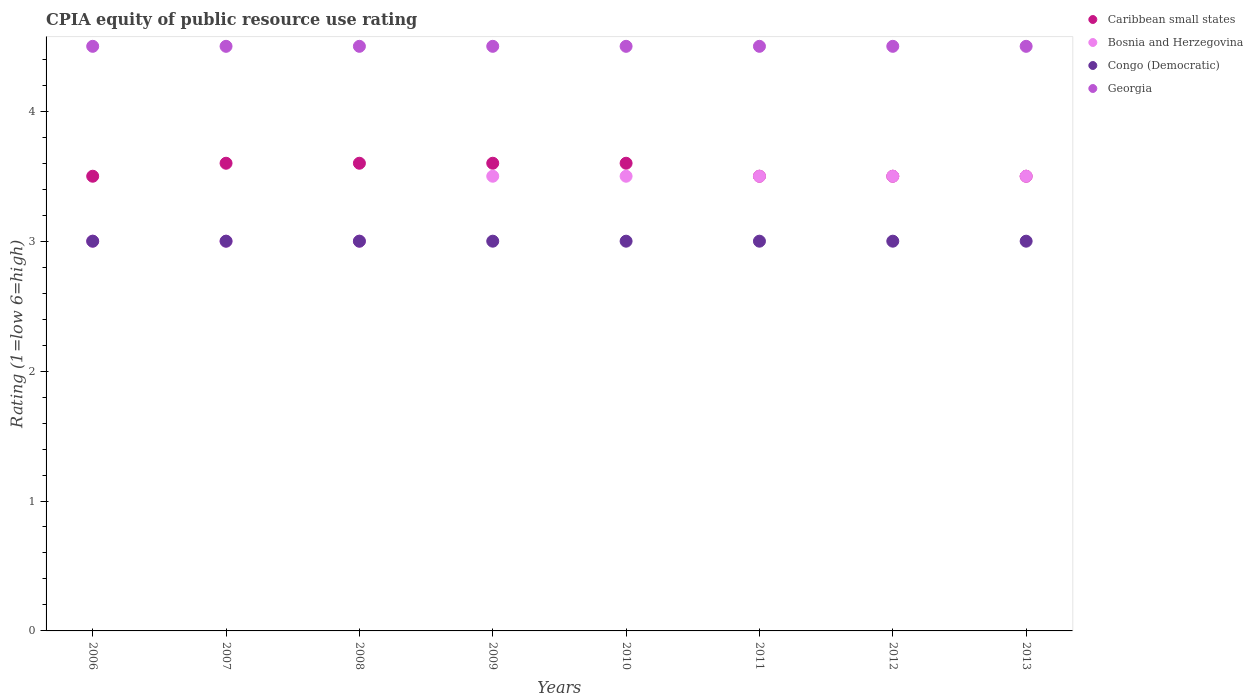How many different coloured dotlines are there?
Keep it short and to the point. 4. Across all years, what is the maximum CPIA rating in Georgia?
Make the answer very short. 4.5. What is the difference between the CPIA rating in Caribbean small states in 2009 and the CPIA rating in Georgia in 2007?
Offer a very short reply. -0.9. What is the average CPIA rating in Caribbean small states per year?
Provide a succinct answer. 3.55. In how many years, is the CPIA rating in Congo (Democratic) greater than 1?
Give a very brief answer. 8. What is the ratio of the CPIA rating in Congo (Democratic) in 2009 to that in 2013?
Your answer should be compact. 1. Is the CPIA rating in Caribbean small states in 2006 less than that in 2011?
Provide a short and direct response. No. Is the difference between the CPIA rating in Bosnia and Herzegovina in 2007 and 2008 greater than the difference between the CPIA rating in Georgia in 2007 and 2008?
Your answer should be compact. No. Is the sum of the CPIA rating in Congo (Democratic) in 2007 and 2009 greater than the maximum CPIA rating in Caribbean small states across all years?
Provide a succinct answer. Yes. Is it the case that in every year, the sum of the CPIA rating in Caribbean small states and CPIA rating in Congo (Democratic)  is greater than the CPIA rating in Bosnia and Herzegovina?
Make the answer very short. Yes. Is the CPIA rating in Congo (Democratic) strictly greater than the CPIA rating in Georgia over the years?
Your response must be concise. No. How many dotlines are there?
Make the answer very short. 4. How many years are there in the graph?
Give a very brief answer. 8. Are the values on the major ticks of Y-axis written in scientific E-notation?
Provide a short and direct response. No. Where does the legend appear in the graph?
Offer a very short reply. Top right. How are the legend labels stacked?
Provide a succinct answer. Vertical. What is the title of the graph?
Offer a very short reply. CPIA equity of public resource use rating. Does "Tuvalu" appear as one of the legend labels in the graph?
Your response must be concise. No. What is the label or title of the Y-axis?
Your answer should be very brief. Rating (1=low 6=high). What is the Rating (1=low 6=high) in Bosnia and Herzegovina in 2006?
Keep it short and to the point. 3. What is the Rating (1=low 6=high) of Congo (Democratic) in 2006?
Your answer should be compact. 3. What is the Rating (1=low 6=high) of Georgia in 2006?
Keep it short and to the point. 4.5. What is the Rating (1=low 6=high) of Caribbean small states in 2007?
Provide a succinct answer. 3.6. What is the Rating (1=low 6=high) of Bosnia and Herzegovina in 2007?
Make the answer very short. 3. What is the Rating (1=low 6=high) in Congo (Democratic) in 2007?
Keep it short and to the point. 3. What is the Rating (1=low 6=high) in Caribbean small states in 2009?
Your response must be concise. 3.6. What is the Rating (1=low 6=high) in Congo (Democratic) in 2009?
Your answer should be very brief. 3. What is the Rating (1=low 6=high) of Caribbean small states in 2010?
Offer a very short reply. 3.6. What is the Rating (1=low 6=high) in Caribbean small states in 2011?
Give a very brief answer. 3.5. What is the Rating (1=low 6=high) of Bosnia and Herzegovina in 2011?
Keep it short and to the point. 3.5. What is the Rating (1=low 6=high) of Caribbean small states in 2012?
Offer a very short reply. 3.5. What is the Rating (1=low 6=high) of Bosnia and Herzegovina in 2013?
Give a very brief answer. 3.5. What is the Rating (1=low 6=high) of Georgia in 2013?
Your answer should be compact. 4.5. Across all years, what is the maximum Rating (1=low 6=high) in Caribbean small states?
Provide a succinct answer. 3.6. Across all years, what is the maximum Rating (1=low 6=high) of Bosnia and Herzegovina?
Provide a short and direct response. 3.5. Across all years, what is the minimum Rating (1=low 6=high) in Bosnia and Herzegovina?
Offer a very short reply. 3. Across all years, what is the minimum Rating (1=low 6=high) of Congo (Democratic)?
Provide a short and direct response. 3. Across all years, what is the minimum Rating (1=low 6=high) in Georgia?
Your response must be concise. 4.5. What is the total Rating (1=low 6=high) in Caribbean small states in the graph?
Ensure brevity in your answer.  28.4. What is the total Rating (1=low 6=high) of Georgia in the graph?
Your answer should be very brief. 36. What is the difference between the Rating (1=low 6=high) in Caribbean small states in 2006 and that in 2008?
Your response must be concise. -0.1. What is the difference between the Rating (1=low 6=high) of Congo (Democratic) in 2006 and that in 2008?
Make the answer very short. 0. What is the difference between the Rating (1=low 6=high) in Bosnia and Herzegovina in 2006 and that in 2009?
Provide a succinct answer. -0.5. What is the difference between the Rating (1=low 6=high) of Bosnia and Herzegovina in 2006 and that in 2010?
Offer a very short reply. -0.5. What is the difference between the Rating (1=low 6=high) of Congo (Democratic) in 2006 and that in 2010?
Offer a very short reply. 0. What is the difference between the Rating (1=low 6=high) in Bosnia and Herzegovina in 2006 and that in 2011?
Keep it short and to the point. -0.5. What is the difference between the Rating (1=low 6=high) of Congo (Democratic) in 2006 and that in 2011?
Your response must be concise. 0. What is the difference between the Rating (1=low 6=high) of Georgia in 2006 and that in 2011?
Give a very brief answer. 0. What is the difference between the Rating (1=low 6=high) in Caribbean small states in 2006 and that in 2012?
Provide a succinct answer. 0. What is the difference between the Rating (1=low 6=high) of Bosnia and Herzegovina in 2006 and that in 2013?
Your answer should be very brief. -0.5. What is the difference between the Rating (1=low 6=high) in Congo (Democratic) in 2006 and that in 2013?
Ensure brevity in your answer.  0. What is the difference between the Rating (1=low 6=high) in Bosnia and Herzegovina in 2007 and that in 2008?
Offer a terse response. 0. What is the difference between the Rating (1=low 6=high) in Congo (Democratic) in 2007 and that in 2008?
Give a very brief answer. 0. What is the difference between the Rating (1=low 6=high) of Georgia in 2007 and that in 2008?
Provide a succinct answer. 0. What is the difference between the Rating (1=low 6=high) in Caribbean small states in 2007 and that in 2009?
Provide a short and direct response. 0. What is the difference between the Rating (1=low 6=high) of Bosnia and Herzegovina in 2007 and that in 2009?
Make the answer very short. -0.5. What is the difference between the Rating (1=low 6=high) of Congo (Democratic) in 2007 and that in 2009?
Give a very brief answer. 0. What is the difference between the Rating (1=low 6=high) in Georgia in 2007 and that in 2009?
Make the answer very short. 0. What is the difference between the Rating (1=low 6=high) of Bosnia and Herzegovina in 2007 and that in 2010?
Offer a terse response. -0.5. What is the difference between the Rating (1=low 6=high) in Caribbean small states in 2007 and that in 2011?
Make the answer very short. 0.1. What is the difference between the Rating (1=low 6=high) in Congo (Democratic) in 2007 and that in 2011?
Your answer should be very brief. 0. What is the difference between the Rating (1=low 6=high) of Caribbean small states in 2007 and that in 2012?
Ensure brevity in your answer.  0.1. What is the difference between the Rating (1=low 6=high) of Congo (Democratic) in 2007 and that in 2012?
Offer a very short reply. 0. What is the difference between the Rating (1=low 6=high) in Bosnia and Herzegovina in 2007 and that in 2013?
Make the answer very short. -0.5. What is the difference between the Rating (1=low 6=high) of Congo (Democratic) in 2007 and that in 2013?
Provide a succinct answer. 0. What is the difference between the Rating (1=low 6=high) of Georgia in 2007 and that in 2013?
Offer a very short reply. 0. What is the difference between the Rating (1=low 6=high) of Bosnia and Herzegovina in 2008 and that in 2009?
Your answer should be very brief. -0.5. What is the difference between the Rating (1=low 6=high) in Congo (Democratic) in 2008 and that in 2010?
Make the answer very short. 0. What is the difference between the Rating (1=low 6=high) in Caribbean small states in 2008 and that in 2011?
Provide a succinct answer. 0.1. What is the difference between the Rating (1=low 6=high) in Congo (Democratic) in 2008 and that in 2011?
Offer a very short reply. 0. What is the difference between the Rating (1=low 6=high) of Georgia in 2008 and that in 2011?
Your answer should be compact. 0. What is the difference between the Rating (1=low 6=high) of Caribbean small states in 2008 and that in 2012?
Offer a terse response. 0.1. What is the difference between the Rating (1=low 6=high) in Bosnia and Herzegovina in 2008 and that in 2012?
Your answer should be compact. -0.5. What is the difference between the Rating (1=low 6=high) in Georgia in 2008 and that in 2012?
Ensure brevity in your answer.  0. What is the difference between the Rating (1=low 6=high) of Caribbean small states in 2008 and that in 2013?
Make the answer very short. 0.1. What is the difference between the Rating (1=low 6=high) in Bosnia and Herzegovina in 2008 and that in 2013?
Your answer should be very brief. -0.5. What is the difference between the Rating (1=low 6=high) in Georgia in 2008 and that in 2013?
Offer a very short reply. 0. What is the difference between the Rating (1=low 6=high) in Bosnia and Herzegovina in 2009 and that in 2010?
Provide a succinct answer. 0. What is the difference between the Rating (1=low 6=high) of Georgia in 2009 and that in 2010?
Make the answer very short. 0. What is the difference between the Rating (1=low 6=high) of Caribbean small states in 2009 and that in 2011?
Offer a terse response. 0.1. What is the difference between the Rating (1=low 6=high) of Bosnia and Herzegovina in 2009 and that in 2011?
Offer a very short reply. 0. What is the difference between the Rating (1=low 6=high) in Bosnia and Herzegovina in 2009 and that in 2012?
Offer a terse response. 0. What is the difference between the Rating (1=low 6=high) of Congo (Democratic) in 2009 and that in 2012?
Your answer should be very brief. 0. What is the difference between the Rating (1=low 6=high) of Caribbean small states in 2009 and that in 2013?
Give a very brief answer. 0.1. What is the difference between the Rating (1=low 6=high) of Bosnia and Herzegovina in 2009 and that in 2013?
Offer a very short reply. 0. What is the difference between the Rating (1=low 6=high) of Congo (Democratic) in 2009 and that in 2013?
Your answer should be compact. 0. What is the difference between the Rating (1=low 6=high) in Caribbean small states in 2010 and that in 2011?
Provide a succinct answer. 0.1. What is the difference between the Rating (1=low 6=high) of Congo (Democratic) in 2010 and that in 2011?
Your answer should be compact. 0. What is the difference between the Rating (1=low 6=high) of Caribbean small states in 2010 and that in 2012?
Your answer should be very brief. 0.1. What is the difference between the Rating (1=low 6=high) of Bosnia and Herzegovina in 2010 and that in 2012?
Keep it short and to the point. 0. What is the difference between the Rating (1=low 6=high) in Congo (Democratic) in 2010 and that in 2012?
Provide a short and direct response. 0. What is the difference between the Rating (1=low 6=high) of Georgia in 2010 and that in 2012?
Provide a short and direct response. 0. What is the difference between the Rating (1=low 6=high) in Caribbean small states in 2010 and that in 2013?
Your answer should be compact. 0.1. What is the difference between the Rating (1=low 6=high) in Bosnia and Herzegovina in 2010 and that in 2013?
Make the answer very short. 0. What is the difference between the Rating (1=low 6=high) in Congo (Democratic) in 2010 and that in 2013?
Make the answer very short. 0. What is the difference between the Rating (1=low 6=high) of Georgia in 2010 and that in 2013?
Offer a terse response. 0. What is the difference between the Rating (1=low 6=high) in Caribbean small states in 2011 and that in 2012?
Make the answer very short. 0. What is the difference between the Rating (1=low 6=high) of Bosnia and Herzegovina in 2011 and that in 2013?
Make the answer very short. 0. What is the difference between the Rating (1=low 6=high) in Congo (Democratic) in 2011 and that in 2013?
Make the answer very short. 0. What is the difference between the Rating (1=low 6=high) of Caribbean small states in 2012 and that in 2013?
Keep it short and to the point. 0. What is the difference between the Rating (1=low 6=high) in Bosnia and Herzegovina in 2012 and that in 2013?
Your answer should be very brief. 0. What is the difference between the Rating (1=low 6=high) in Georgia in 2012 and that in 2013?
Make the answer very short. 0. What is the difference between the Rating (1=low 6=high) of Congo (Democratic) in 2006 and the Rating (1=low 6=high) of Georgia in 2007?
Offer a terse response. -1.5. What is the difference between the Rating (1=low 6=high) of Caribbean small states in 2006 and the Rating (1=low 6=high) of Bosnia and Herzegovina in 2008?
Make the answer very short. 0.5. What is the difference between the Rating (1=low 6=high) of Caribbean small states in 2006 and the Rating (1=low 6=high) of Congo (Democratic) in 2008?
Keep it short and to the point. 0.5. What is the difference between the Rating (1=low 6=high) in Bosnia and Herzegovina in 2006 and the Rating (1=low 6=high) in Congo (Democratic) in 2008?
Provide a succinct answer. 0. What is the difference between the Rating (1=low 6=high) in Bosnia and Herzegovina in 2006 and the Rating (1=low 6=high) in Georgia in 2008?
Provide a succinct answer. -1.5. What is the difference between the Rating (1=low 6=high) in Caribbean small states in 2006 and the Rating (1=low 6=high) in Congo (Democratic) in 2009?
Your answer should be compact. 0.5. What is the difference between the Rating (1=low 6=high) in Caribbean small states in 2006 and the Rating (1=low 6=high) in Congo (Democratic) in 2010?
Ensure brevity in your answer.  0.5. What is the difference between the Rating (1=low 6=high) of Bosnia and Herzegovina in 2006 and the Rating (1=low 6=high) of Congo (Democratic) in 2010?
Keep it short and to the point. 0. What is the difference between the Rating (1=low 6=high) of Caribbean small states in 2006 and the Rating (1=low 6=high) of Bosnia and Herzegovina in 2011?
Make the answer very short. 0. What is the difference between the Rating (1=low 6=high) of Caribbean small states in 2006 and the Rating (1=low 6=high) of Congo (Democratic) in 2011?
Your answer should be very brief. 0.5. What is the difference between the Rating (1=low 6=high) in Caribbean small states in 2006 and the Rating (1=low 6=high) in Georgia in 2011?
Offer a terse response. -1. What is the difference between the Rating (1=low 6=high) in Bosnia and Herzegovina in 2006 and the Rating (1=low 6=high) in Georgia in 2011?
Your answer should be compact. -1.5. What is the difference between the Rating (1=low 6=high) in Caribbean small states in 2006 and the Rating (1=low 6=high) in Bosnia and Herzegovina in 2012?
Provide a short and direct response. 0. What is the difference between the Rating (1=low 6=high) in Caribbean small states in 2006 and the Rating (1=low 6=high) in Georgia in 2012?
Your answer should be compact. -1. What is the difference between the Rating (1=low 6=high) of Caribbean small states in 2006 and the Rating (1=low 6=high) of Congo (Democratic) in 2013?
Your answer should be very brief. 0.5. What is the difference between the Rating (1=low 6=high) in Bosnia and Herzegovina in 2006 and the Rating (1=low 6=high) in Congo (Democratic) in 2013?
Your answer should be very brief. 0. What is the difference between the Rating (1=low 6=high) of Congo (Democratic) in 2006 and the Rating (1=low 6=high) of Georgia in 2013?
Offer a very short reply. -1.5. What is the difference between the Rating (1=low 6=high) in Caribbean small states in 2007 and the Rating (1=low 6=high) in Congo (Democratic) in 2008?
Your answer should be very brief. 0.6. What is the difference between the Rating (1=low 6=high) in Congo (Democratic) in 2007 and the Rating (1=low 6=high) in Georgia in 2008?
Give a very brief answer. -1.5. What is the difference between the Rating (1=low 6=high) of Caribbean small states in 2007 and the Rating (1=low 6=high) of Congo (Democratic) in 2009?
Keep it short and to the point. 0.6. What is the difference between the Rating (1=low 6=high) in Caribbean small states in 2007 and the Rating (1=low 6=high) in Georgia in 2009?
Offer a very short reply. -0.9. What is the difference between the Rating (1=low 6=high) of Bosnia and Herzegovina in 2007 and the Rating (1=low 6=high) of Georgia in 2009?
Your answer should be very brief. -1.5. What is the difference between the Rating (1=low 6=high) of Caribbean small states in 2007 and the Rating (1=low 6=high) of Bosnia and Herzegovina in 2010?
Your answer should be compact. 0.1. What is the difference between the Rating (1=low 6=high) of Caribbean small states in 2007 and the Rating (1=low 6=high) of Georgia in 2010?
Your answer should be compact. -0.9. What is the difference between the Rating (1=low 6=high) in Bosnia and Herzegovina in 2007 and the Rating (1=low 6=high) in Congo (Democratic) in 2010?
Provide a short and direct response. 0. What is the difference between the Rating (1=low 6=high) of Bosnia and Herzegovina in 2007 and the Rating (1=low 6=high) of Georgia in 2010?
Offer a very short reply. -1.5. What is the difference between the Rating (1=low 6=high) of Congo (Democratic) in 2007 and the Rating (1=low 6=high) of Georgia in 2010?
Give a very brief answer. -1.5. What is the difference between the Rating (1=low 6=high) in Bosnia and Herzegovina in 2007 and the Rating (1=low 6=high) in Congo (Democratic) in 2011?
Make the answer very short. 0. What is the difference between the Rating (1=low 6=high) in Congo (Democratic) in 2007 and the Rating (1=low 6=high) in Georgia in 2011?
Give a very brief answer. -1.5. What is the difference between the Rating (1=low 6=high) of Caribbean small states in 2007 and the Rating (1=low 6=high) of Congo (Democratic) in 2012?
Ensure brevity in your answer.  0.6. What is the difference between the Rating (1=low 6=high) in Bosnia and Herzegovina in 2007 and the Rating (1=low 6=high) in Congo (Democratic) in 2012?
Keep it short and to the point. 0. What is the difference between the Rating (1=low 6=high) in Bosnia and Herzegovina in 2007 and the Rating (1=low 6=high) in Georgia in 2012?
Offer a very short reply. -1.5. What is the difference between the Rating (1=low 6=high) in Congo (Democratic) in 2007 and the Rating (1=low 6=high) in Georgia in 2012?
Your response must be concise. -1.5. What is the difference between the Rating (1=low 6=high) in Caribbean small states in 2007 and the Rating (1=low 6=high) in Georgia in 2013?
Provide a succinct answer. -0.9. What is the difference between the Rating (1=low 6=high) of Bosnia and Herzegovina in 2007 and the Rating (1=low 6=high) of Congo (Democratic) in 2013?
Offer a terse response. 0. What is the difference between the Rating (1=low 6=high) of Congo (Democratic) in 2007 and the Rating (1=low 6=high) of Georgia in 2013?
Your answer should be compact. -1.5. What is the difference between the Rating (1=low 6=high) of Caribbean small states in 2008 and the Rating (1=low 6=high) of Georgia in 2009?
Provide a short and direct response. -0.9. What is the difference between the Rating (1=low 6=high) in Congo (Democratic) in 2008 and the Rating (1=low 6=high) in Georgia in 2009?
Provide a succinct answer. -1.5. What is the difference between the Rating (1=low 6=high) in Caribbean small states in 2008 and the Rating (1=low 6=high) in Bosnia and Herzegovina in 2010?
Ensure brevity in your answer.  0.1. What is the difference between the Rating (1=low 6=high) of Caribbean small states in 2008 and the Rating (1=low 6=high) of Congo (Democratic) in 2010?
Ensure brevity in your answer.  0.6. What is the difference between the Rating (1=low 6=high) in Caribbean small states in 2008 and the Rating (1=low 6=high) in Georgia in 2010?
Provide a succinct answer. -0.9. What is the difference between the Rating (1=low 6=high) in Bosnia and Herzegovina in 2008 and the Rating (1=low 6=high) in Congo (Democratic) in 2010?
Your answer should be compact. 0. What is the difference between the Rating (1=low 6=high) in Caribbean small states in 2008 and the Rating (1=low 6=high) in Bosnia and Herzegovina in 2011?
Your answer should be very brief. 0.1. What is the difference between the Rating (1=low 6=high) in Caribbean small states in 2008 and the Rating (1=low 6=high) in Georgia in 2011?
Your answer should be compact. -0.9. What is the difference between the Rating (1=low 6=high) of Bosnia and Herzegovina in 2008 and the Rating (1=low 6=high) of Georgia in 2011?
Keep it short and to the point. -1.5. What is the difference between the Rating (1=low 6=high) in Congo (Democratic) in 2008 and the Rating (1=low 6=high) in Georgia in 2011?
Your answer should be very brief. -1.5. What is the difference between the Rating (1=low 6=high) of Caribbean small states in 2008 and the Rating (1=low 6=high) of Bosnia and Herzegovina in 2012?
Offer a very short reply. 0.1. What is the difference between the Rating (1=low 6=high) in Caribbean small states in 2008 and the Rating (1=low 6=high) in Georgia in 2012?
Your answer should be compact. -0.9. What is the difference between the Rating (1=low 6=high) in Bosnia and Herzegovina in 2008 and the Rating (1=low 6=high) in Congo (Democratic) in 2012?
Offer a very short reply. 0. What is the difference between the Rating (1=low 6=high) in Bosnia and Herzegovina in 2008 and the Rating (1=low 6=high) in Georgia in 2012?
Offer a very short reply. -1.5. What is the difference between the Rating (1=low 6=high) in Congo (Democratic) in 2008 and the Rating (1=low 6=high) in Georgia in 2012?
Give a very brief answer. -1.5. What is the difference between the Rating (1=low 6=high) of Caribbean small states in 2008 and the Rating (1=low 6=high) of Bosnia and Herzegovina in 2013?
Ensure brevity in your answer.  0.1. What is the difference between the Rating (1=low 6=high) in Caribbean small states in 2008 and the Rating (1=low 6=high) in Congo (Democratic) in 2013?
Ensure brevity in your answer.  0.6. What is the difference between the Rating (1=low 6=high) of Bosnia and Herzegovina in 2008 and the Rating (1=low 6=high) of Congo (Democratic) in 2013?
Offer a terse response. 0. What is the difference between the Rating (1=low 6=high) in Bosnia and Herzegovina in 2008 and the Rating (1=low 6=high) in Georgia in 2013?
Make the answer very short. -1.5. What is the difference between the Rating (1=low 6=high) of Caribbean small states in 2009 and the Rating (1=low 6=high) of Bosnia and Herzegovina in 2010?
Ensure brevity in your answer.  0.1. What is the difference between the Rating (1=low 6=high) in Bosnia and Herzegovina in 2009 and the Rating (1=low 6=high) in Georgia in 2010?
Offer a very short reply. -1. What is the difference between the Rating (1=low 6=high) in Caribbean small states in 2009 and the Rating (1=low 6=high) in Bosnia and Herzegovina in 2011?
Offer a terse response. 0.1. What is the difference between the Rating (1=low 6=high) in Caribbean small states in 2009 and the Rating (1=low 6=high) in Georgia in 2011?
Provide a succinct answer. -0.9. What is the difference between the Rating (1=low 6=high) in Congo (Democratic) in 2009 and the Rating (1=low 6=high) in Georgia in 2011?
Provide a succinct answer. -1.5. What is the difference between the Rating (1=low 6=high) in Caribbean small states in 2009 and the Rating (1=low 6=high) in Bosnia and Herzegovina in 2012?
Offer a very short reply. 0.1. What is the difference between the Rating (1=low 6=high) of Caribbean small states in 2009 and the Rating (1=low 6=high) of Congo (Democratic) in 2012?
Offer a very short reply. 0.6. What is the difference between the Rating (1=low 6=high) in Bosnia and Herzegovina in 2009 and the Rating (1=low 6=high) in Georgia in 2012?
Your answer should be compact. -1. What is the difference between the Rating (1=low 6=high) in Caribbean small states in 2009 and the Rating (1=low 6=high) in Congo (Democratic) in 2013?
Offer a terse response. 0.6. What is the difference between the Rating (1=low 6=high) in Bosnia and Herzegovina in 2009 and the Rating (1=low 6=high) in Georgia in 2013?
Ensure brevity in your answer.  -1. What is the difference between the Rating (1=low 6=high) in Congo (Democratic) in 2009 and the Rating (1=low 6=high) in Georgia in 2013?
Your answer should be compact. -1.5. What is the difference between the Rating (1=low 6=high) of Caribbean small states in 2010 and the Rating (1=low 6=high) of Georgia in 2011?
Your response must be concise. -0.9. What is the difference between the Rating (1=low 6=high) of Bosnia and Herzegovina in 2010 and the Rating (1=low 6=high) of Congo (Democratic) in 2011?
Offer a very short reply. 0.5. What is the difference between the Rating (1=low 6=high) of Bosnia and Herzegovina in 2010 and the Rating (1=low 6=high) of Georgia in 2011?
Offer a terse response. -1. What is the difference between the Rating (1=low 6=high) in Caribbean small states in 2010 and the Rating (1=low 6=high) in Georgia in 2012?
Provide a succinct answer. -0.9. What is the difference between the Rating (1=low 6=high) in Bosnia and Herzegovina in 2010 and the Rating (1=low 6=high) in Congo (Democratic) in 2012?
Offer a very short reply. 0.5. What is the difference between the Rating (1=low 6=high) in Caribbean small states in 2010 and the Rating (1=low 6=high) in Bosnia and Herzegovina in 2013?
Your response must be concise. 0.1. What is the difference between the Rating (1=low 6=high) of Caribbean small states in 2010 and the Rating (1=low 6=high) of Congo (Democratic) in 2013?
Keep it short and to the point. 0.6. What is the difference between the Rating (1=low 6=high) in Bosnia and Herzegovina in 2010 and the Rating (1=low 6=high) in Congo (Democratic) in 2013?
Offer a terse response. 0.5. What is the difference between the Rating (1=low 6=high) of Bosnia and Herzegovina in 2010 and the Rating (1=low 6=high) of Georgia in 2013?
Your answer should be very brief. -1. What is the difference between the Rating (1=low 6=high) of Congo (Democratic) in 2010 and the Rating (1=low 6=high) of Georgia in 2013?
Your answer should be compact. -1.5. What is the difference between the Rating (1=low 6=high) of Caribbean small states in 2011 and the Rating (1=low 6=high) of Congo (Democratic) in 2012?
Your response must be concise. 0.5. What is the difference between the Rating (1=low 6=high) in Bosnia and Herzegovina in 2011 and the Rating (1=low 6=high) in Georgia in 2012?
Provide a succinct answer. -1. What is the difference between the Rating (1=low 6=high) of Congo (Democratic) in 2011 and the Rating (1=low 6=high) of Georgia in 2012?
Provide a short and direct response. -1.5. What is the difference between the Rating (1=low 6=high) in Caribbean small states in 2011 and the Rating (1=low 6=high) in Bosnia and Herzegovina in 2013?
Ensure brevity in your answer.  0. What is the difference between the Rating (1=low 6=high) in Bosnia and Herzegovina in 2011 and the Rating (1=low 6=high) in Georgia in 2013?
Make the answer very short. -1. What is the difference between the Rating (1=low 6=high) in Congo (Democratic) in 2011 and the Rating (1=low 6=high) in Georgia in 2013?
Your response must be concise. -1.5. What is the difference between the Rating (1=low 6=high) in Caribbean small states in 2012 and the Rating (1=low 6=high) in Bosnia and Herzegovina in 2013?
Offer a very short reply. 0. What is the difference between the Rating (1=low 6=high) in Caribbean small states in 2012 and the Rating (1=low 6=high) in Congo (Democratic) in 2013?
Offer a terse response. 0.5. What is the difference between the Rating (1=low 6=high) in Caribbean small states in 2012 and the Rating (1=low 6=high) in Georgia in 2013?
Your response must be concise. -1. What is the difference between the Rating (1=low 6=high) of Bosnia and Herzegovina in 2012 and the Rating (1=low 6=high) of Georgia in 2013?
Your response must be concise. -1. What is the difference between the Rating (1=low 6=high) in Congo (Democratic) in 2012 and the Rating (1=low 6=high) in Georgia in 2013?
Offer a terse response. -1.5. What is the average Rating (1=low 6=high) of Caribbean small states per year?
Give a very brief answer. 3.55. What is the average Rating (1=low 6=high) in Bosnia and Herzegovina per year?
Provide a succinct answer. 3.31. What is the average Rating (1=low 6=high) in Congo (Democratic) per year?
Offer a very short reply. 3. In the year 2006, what is the difference between the Rating (1=low 6=high) of Caribbean small states and Rating (1=low 6=high) of Congo (Democratic)?
Make the answer very short. 0.5. In the year 2006, what is the difference between the Rating (1=low 6=high) in Bosnia and Herzegovina and Rating (1=low 6=high) in Congo (Democratic)?
Your answer should be compact. 0. In the year 2007, what is the difference between the Rating (1=low 6=high) in Caribbean small states and Rating (1=low 6=high) in Bosnia and Herzegovina?
Your answer should be very brief. 0.6. In the year 2008, what is the difference between the Rating (1=low 6=high) in Caribbean small states and Rating (1=low 6=high) in Georgia?
Your answer should be very brief. -0.9. In the year 2008, what is the difference between the Rating (1=low 6=high) in Bosnia and Herzegovina and Rating (1=low 6=high) in Congo (Democratic)?
Your response must be concise. 0. In the year 2008, what is the difference between the Rating (1=low 6=high) in Bosnia and Herzegovina and Rating (1=low 6=high) in Georgia?
Give a very brief answer. -1.5. In the year 2009, what is the difference between the Rating (1=low 6=high) in Caribbean small states and Rating (1=low 6=high) in Congo (Democratic)?
Your response must be concise. 0.6. In the year 2009, what is the difference between the Rating (1=low 6=high) in Bosnia and Herzegovina and Rating (1=low 6=high) in Georgia?
Your response must be concise. -1. In the year 2009, what is the difference between the Rating (1=low 6=high) of Congo (Democratic) and Rating (1=low 6=high) of Georgia?
Your response must be concise. -1.5. In the year 2010, what is the difference between the Rating (1=low 6=high) in Bosnia and Herzegovina and Rating (1=low 6=high) in Congo (Democratic)?
Your answer should be compact. 0.5. In the year 2011, what is the difference between the Rating (1=low 6=high) in Caribbean small states and Rating (1=low 6=high) in Bosnia and Herzegovina?
Provide a succinct answer. 0. In the year 2011, what is the difference between the Rating (1=low 6=high) of Caribbean small states and Rating (1=low 6=high) of Congo (Democratic)?
Offer a very short reply. 0.5. In the year 2011, what is the difference between the Rating (1=low 6=high) in Bosnia and Herzegovina and Rating (1=low 6=high) in Georgia?
Make the answer very short. -1. In the year 2011, what is the difference between the Rating (1=low 6=high) in Congo (Democratic) and Rating (1=low 6=high) in Georgia?
Keep it short and to the point. -1.5. In the year 2012, what is the difference between the Rating (1=low 6=high) in Caribbean small states and Rating (1=low 6=high) in Congo (Democratic)?
Offer a very short reply. 0.5. In the year 2012, what is the difference between the Rating (1=low 6=high) in Bosnia and Herzegovina and Rating (1=low 6=high) in Congo (Democratic)?
Offer a terse response. 0.5. In the year 2012, what is the difference between the Rating (1=low 6=high) in Bosnia and Herzegovina and Rating (1=low 6=high) in Georgia?
Your answer should be very brief. -1. In the year 2012, what is the difference between the Rating (1=low 6=high) of Congo (Democratic) and Rating (1=low 6=high) of Georgia?
Your answer should be compact. -1.5. In the year 2013, what is the difference between the Rating (1=low 6=high) in Bosnia and Herzegovina and Rating (1=low 6=high) in Congo (Democratic)?
Offer a very short reply. 0.5. In the year 2013, what is the difference between the Rating (1=low 6=high) in Bosnia and Herzegovina and Rating (1=low 6=high) in Georgia?
Ensure brevity in your answer.  -1. In the year 2013, what is the difference between the Rating (1=low 6=high) of Congo (Democratic) and Rating (1=low 6=high) of Georgia?
Your answer should be compact. -1.5. What is the ratio of the Rating (1=low 6=high) of Caribbean small states in 2006 to that in 2007?
Provide a succinct answer. 0.97. What is the ratio of the Rating (1=low 6=high) of Congo (Democratic) in 2006 to that in 2007?
Provide a succinct answer. 1. What is the ratio of the Rating (1=low 6=high) in Caribbean small states in 2006 to that in 2008?
Offer a very short reply. 0.97. What is the ratio of the Rating (1=low 6=high) of Caribbean small states in 2006 to that in 2009?
Your answer should be very brief. 0.97. What is the ratio of the Rating (1=low 6=high) in Bosnia and Herzegovina in 2006 to that in 2009?
Offer a terse response. 0.86. What is the ratio of the Rating (1=low 6=high) of Georgia in 2006 to that in 2009?
Your answer should be very brief. 1. What is the ratio of the Rating (1=low 6=high) in Caribbean small states in 2006 to that in 2010?
Your response must be concise. 0.97. What is the ratio of the Rating (1=low 6=high) of Caribbean small states in 2006 to that in 2011?
Offer a very short reply. 1. What is the ratio of the Rating (1=low 6=high) of Bosnia and Herzegovina in 2006 to that in 2011?
Provide a short and direct response. 0.86. What is the ratio of the Rating (1=low 6=high) in Congo (Democratic) in 2006 to that in 2011?
Ensure brevity in your answer.  1. What is the ratio of the Rating (1=low 6=high) in Caribbean small states in 2006 to that in 2012?
Make the answer very short. 1. What is the ratio of the Rating (1=low 6=high) in Bosnia and Herzegovina in 2006 to that in 2012?
Keep it short and to the point. 0.86. What is the ratio of the Rating (1=low 6=high) of Georgia in 2006 to that in 2012?
Give a very brief answer. 1. What is the ratio of the Rating (1=low 6=high) in Bosnia and Herzegovina in 2007 to that in 2008?
Offer a very short reply. 1. What is the ratio of the Rating (1=low 6=high) of Georgia in 2007 to that in 2008?
Your answer should be compact. 1. What is the ratio of the Rating (1=low 6=high) of Congo (Democratic) in 2007 to that in 2009?
Ensure brevity in your answer.  1. What is the ratio of the Rating (1=low 6=high) in Bosnia and Herzegovina in 2007 to that in 2010?
Your answer should be very brief. 0.86. What is the ratio of the Rating (1=low 6=high) in Georgia in 2007 to that in 2010?
Provide a short and direct response. 1. What is the ratio of the Rating (1=low 6=high) of Caribbean small states in 2007 to that in 2011?
Keep it short and to the point. 1.03. What is the ratio of the Rating (1=low 6=high) in Bosnia and Herzegovina in 2007 to that in 2011?
Your answer should be very brief. 0.86. What is the ratio of the Rating (1=low 6=high) of Congo (Democratic) in 2007 to that in 2011?
Keep it short and to the point. 1. What is the ratio of the Rating (1=low 6=high) in Caribbean small states in 2007 to that in 2012?
Your answer should be very brief. 1.03. What is the ratio of the Rating (1=low 6=high) of Congo (Democratic) in 2007 to that in 2012?
Offer a terse response. 1. What is the ratio of the Rating (1=low 6=high) in Georgia in 2007 to that in 2012?
Your answer should be compact. 1. What is the ratio of the Rating (1=low 6=high) of Caribbean small states in 2007 to that in 2013?
Offer a very short reply. 1.03. What is the ratio of the Rating (1=low 6=high) in Bosnia and Herzegovina in 2007 to that in 2013?
Provide a succinct answer. 0.86. What is the ratio of the Rating (1=low 6=high) in Congo (Democratic) in 2007 to that in 2013?
Offer a very short reply. 1. What is the ratio of the Rating (1=low 6=high) of Bosnia and Herzegovina in 2008 to that in 2009?
Offer a very short reply. 0.86. What is the ratio of the Rating (1=low 6=high) of Georgia in 2008 to that in 2010?
Offer a terse response. 1. What is the ratio of the Rating (1=low 6=high) in Caribbean small states in 2008 to that in 2011?
Offer a very short reply. 1.03. What is the ratio of the Rating (1=low 6=high) in Congo (Democratic) in 2008 to that in 2011?
Provide a short and direct response. 1. What is the ratio of the Rating (1=low 6=high) in Caribbean small states in 2008 to that in 2012?
Your response must be concise. 1.03. What is the ratio of the Rating (1=low 6=high) of Congo (Democratic) in 2008 to that in 2012?
Keep it short and to the point. 1. What is the ratio of the Rating (1=low 6=high) of Caribbean small states in 2008 to that in 2013?
Ensure brevity in your answer.  1.03. What is the ratio of the Rating (1=low 6=high) of Bosnia and Herzegovina in 2008 to that in 2013?
Provide a short and direct response. 0.86. What is the ratio of the Rating (1=low 6=high) in Georgia in 2008 to that in 2013?
Provide a succinct answer. 1. What is the ratio of the Rating (1=low 6=high) of Caribbean small states in 2009 to that in 2010?
Give a very brief answer. 1. What is the ratio of the Rating (1=low 6=high) of Bosnia and Herzegovina in 2009 to that in 2010?
Your response must be concise. 1. What is the ratio of the Rating (1=low 6=high) in Congo (Democratic) in 2009 to that in 2010?
Ensure brevity in your answer.  1. What is the ratio of the Rating (1=low 6=high) in Georgia in 2009 to that in 2010?
Provide a short and direct response. 1. What is the ratio of the Rating (1=low 6=high) of Caribbean small states in 2009 to that in 2011?
Offer a terse response. 1.03. What is the ratio of the Rating (1=low 6=high) of Congo (Democratic) in 2009 to that in 2011?
Offer a very short reply. 1. What is the ratio of the Rating (1=low 6=high) in Georgia in 2009 to that in 2011?
Keep it short and to the point. 1. What is the ratio of the Rating (1=low 6=high) of Caribbean small states in 2009 to that in 2012?
Make the answer very short. 1.03. What is the ratio of the Rating (1=low 6=high) of Bosnia and Herzegovina in 2009 to that in 2012?
Offer a very short reply. 1. What is the ratio of the Rating (1=low 6=high) of Caribbean small states in 2009 to that in 2013?
Offer a terse response. 1.03. What is the ratio of the Rating (1=low 6=high) in Georgia in 2009 to that in 2013?
Your answer should be compact. 1. What is the ratio of the Rating (1=low 6=high) of Caribbean small states in 2010 to that in 2011?
Keep it short and to the point. 1.03. What is the ratio of the Rating (1=low 6=high) in Bosnia and Herzegovina in 2010 to that in 2011?
Offer a terse response. 1. What is the ratio of the Rating (1=low 6=high) in Georgia in 2010 to that in 2011?
Your answer should be compact. 1. What is the ratio of the Rating (1=low 6=high) of Caribbean small states in 2010 to that in 2012?
Give a very brief answer. 1.03. What is the ratio of the Rating (1=low 6=high) of Bosnia and Herzegovina in 2010 to that in 2012?
Offer a terse response. 1. What is the ratio of the Rating (1=low 6=high) in Georgia in 2010 to that in 2012?
Make the answer very short. 1. What is the ratio of the Rating (1=low 6=high) in Caribbean small states in 2010 to that in 2013?
Your response must be concise. 1.03. What is the ratio of the Rating (1=low 6=high) in Bosnia and Herzegovina in 2010 to that in 2013?
Give a very brief answer. 1. What is the ratio of the Rating (1=low 6=high) in Bosnia and Herzegovina in 2011 to that in 2012?
Provide a short and direct response. 1. What is the ratio of the Rating (1=low 6=high) of Congo (Democratic) in 2011 to that in 2012?
Offer a terse response. 1. What is the ratio of the Rating (1=low 6=high) of Georgia in 2011 to that in 2012?
Keep it short and to the point. 1. What is the ratio of the Rating (1=low 6=high) of Caribbean small states in 2011 to that in 2013?
Provide a short and direct response. 1. What is the ratio of the Rating (1=low 6=high) of Congo (Democratic) in 2011 to that in 2013?
Keep it short and to the point. 1. What is the ratio of the Rating (1=low 6=high) of Georgia in 2011 to that in 2013?
Make the answer very short. 1. What is the difference between the highest and the second highest Rating (1=low 6=high) in Caribbean small states?
Your answer should be compact. 0. What is the difference between the highest and the second highest Rating (1=low 6=high) of Bosnia and Herzegovina?
Offer a terse response. 0. What is the difference between the highest and the second highest Rating (1=low 6=high) of Georgia?
Your answer should be compact. 0. What is the difference between the highest and the lowest Rating (1=low 6=high) in Caribbean small states?
Give a very brief answer. 0.1. 